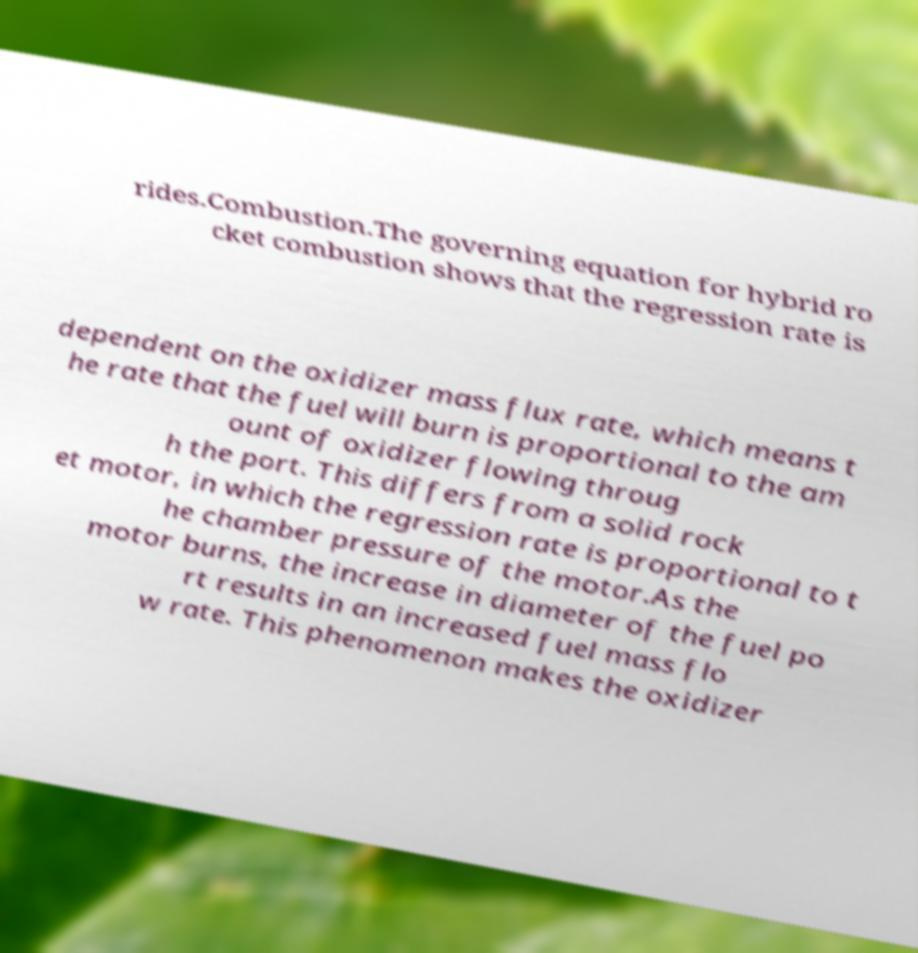Can you accurately transcribe the text from the provided image for me? rides.Combustion.The governing equation for hybrid ro cket combustion shows that the regression rate is dependent on the oxidizer mass flux rate, which means t he rate that the fuel will burn is proportional to the am ount of oxidizer flowing throug h the port. This differs from a solid rock et motor, in which the regression rate is proportional to t he chamber pressure of the motor.As the motor burns, the increase in diameter of the fuel po rt results in an increased fuel mass flo w rate. This phenomenon makes the oxidizer 